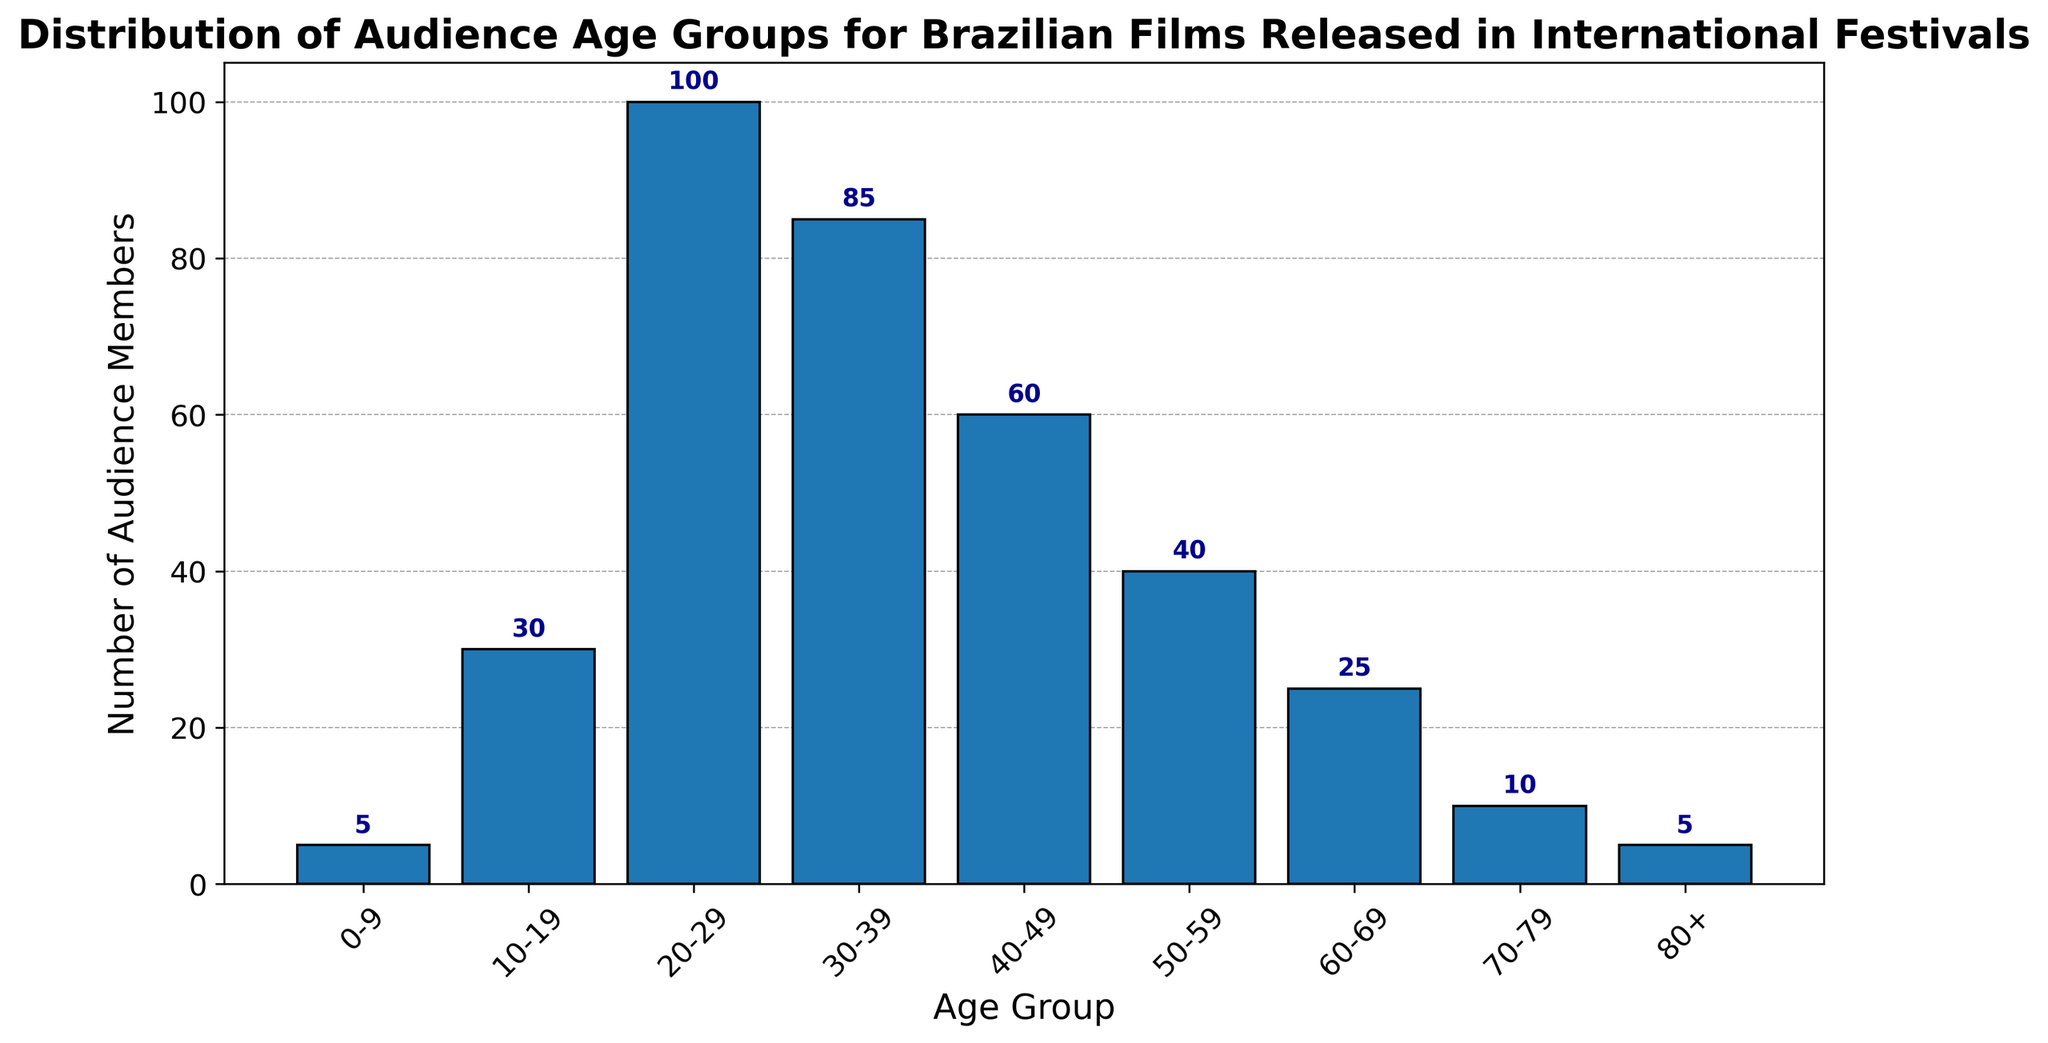What is the age group with the highest number of audience members? The tallest bar represents the age group with the highest number of audience members. According to the data, the tallest bar corresponds to the 20-29 age group.
Answer: 20-29 How many total audience members are there in age groups 10-19 and 50-59 combined? Adding the counts of the 10-19 and 50-59 age groups gives us the total. From the data, 10-19 has 30 members and 50-59 has 40 members, so 30 + 40 = 70.
Answer: 70 Which age group has fewer audience members, 40-49 or 60-69? By comparing the heights of the bars for 40-49 and 60-69 age groups, we see that 60-69 has fewer audience members. 40-49 has 60 members, while 60-69 has 25.
Answer: 60-69 What is the total number of audience members for all age groups depicted in the histogram? Summing up the counts from all age groups: 5 (0-9) + 30 (10-19) + 100 (20-29) + 85 (30-39) + 60 (40-49) + 40 (50-59) + 25 (60-69) + 10 (70-79) + 5 (80+). This results in a total of 360.
Answer: 360 Between the age groups 30-39 and 40-49, which has more audience members, and by how much? The bar for 30-39 is taller than the one for 40-49. 30-39 has 85 members and 40-49 has 60. The difference is 85 - 60 = 25.
Answer: 30-39, by 25 members What proportion of the audience is in the 20-29 age group? To find the proportion, divide the number of audience members in the 20-29 age group by the total audience members. 20-29 has 100 members, and the total is 360. So, 100 / 360 ≈ 0.28 or 28%.
Answer: 28% Which age group with fewer than 30 audience members has the highest count? Among the groups with fewer than 30 members (0-9, 60-69, 70-79, and 80+), the bar for 60-69 is the tallest. It has 25 members.
Answer: 60-69 How does the number of audience members in the 30-39 age group compare to those aged 60 and above (60-69, 70-79, 80+)? Summing the counts for age groups 60 and above: 25 (60-69) + 10 (70-79) + 5 (80+) = 40. Comparing this to the 85 members in the 30-39 age group, 30-39 has more members.
Answer: 30-39 has more Which age groups have exactly 5 audience members? The bars for age groups 0-9 and 80+ both correspond to 5 audience members according to the data.
Answer: 0-9 and 80+ What is the average number of audience members per age group? To calculate the average, divide the total number of audience members by the number of age groups. The total is 360, and there are 9 age groups. So, 360 / 9 = 40.
Answer: 40 